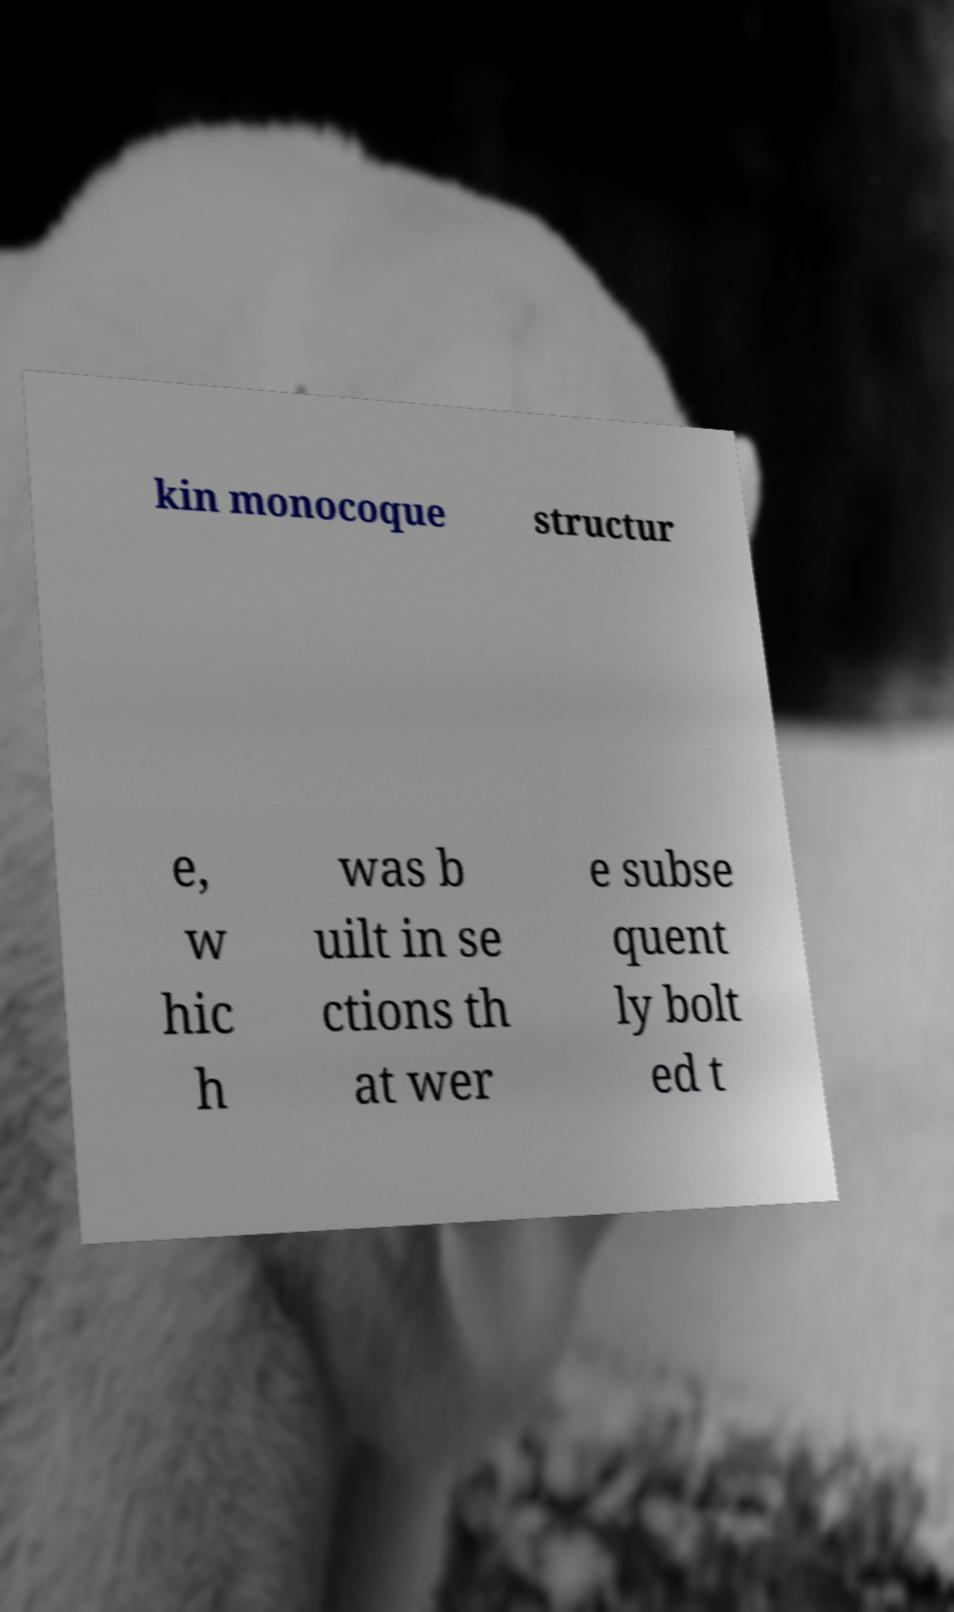What messages or text are displayed in this image? I need them in a readable, typed format. kin monocoque structur e, w hic h was b uilt in se ctions th at wer e subse quent ly bolt ed t 